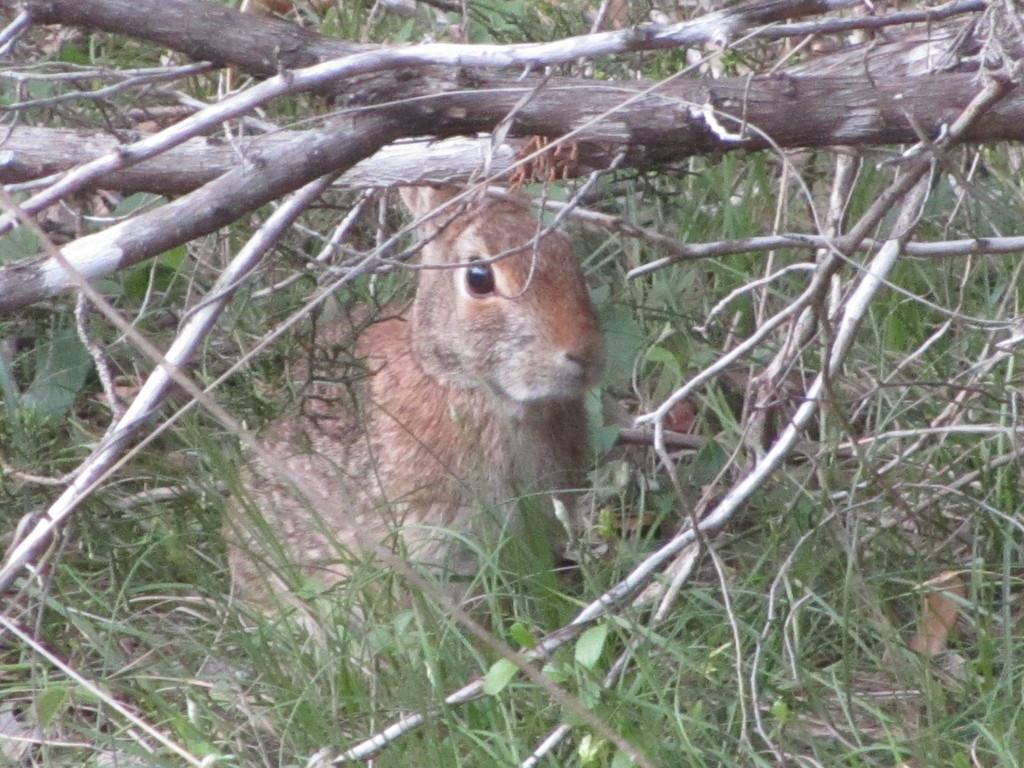Please provide a concise description of this image. In the image we can see some stems and grass. Behind them we can see a rabbit. 